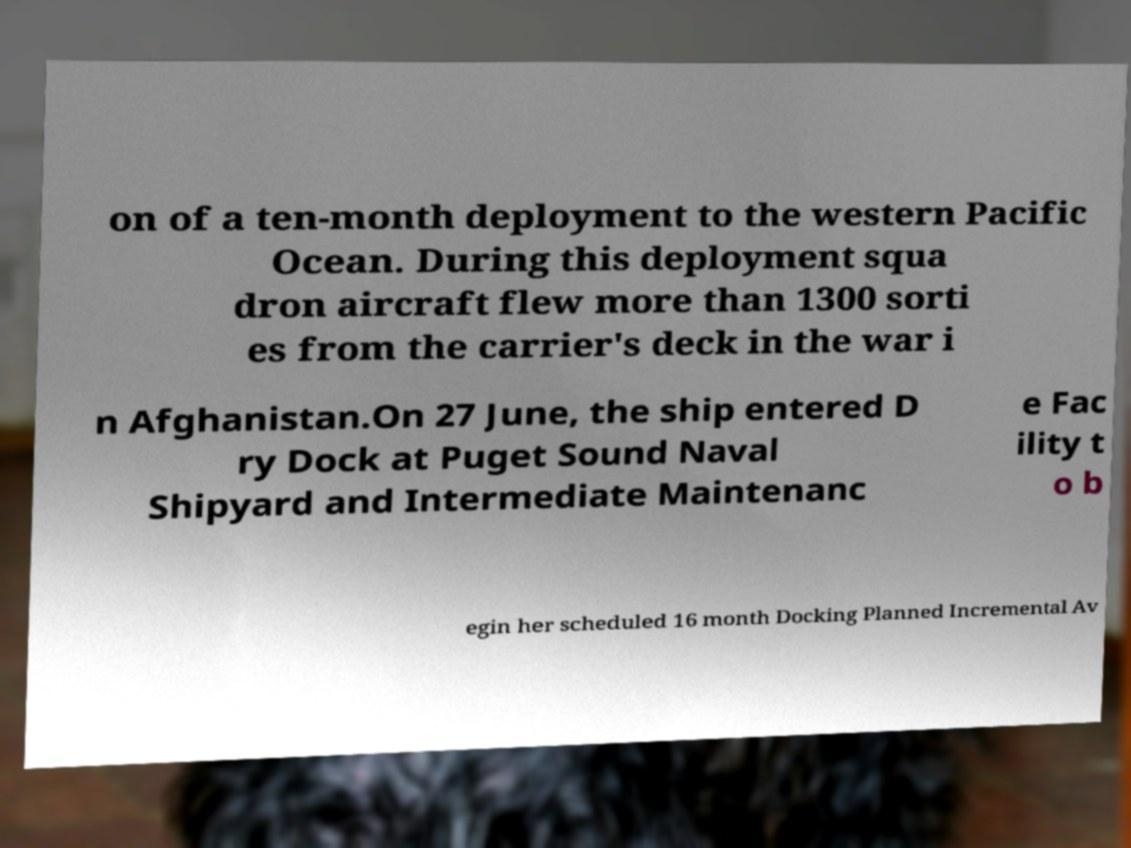Can you read and provide the text displayed in the image?This photo seems to have some interesting text. Can you extract and type it out for me? on of a ten-month deployment to the western Pacific Ocean. During this deployment squa dron aircraft flew more than 1300 sorti es from the carrier's deck in the war i n Afghanistan.On 27 June, the ship entered D ry Dock at Puget Sound Naval Shipyard and Intermediate Maintenanc e Fac ility t o b egin her scheduled 16 month Docking Planned Incremental Av 